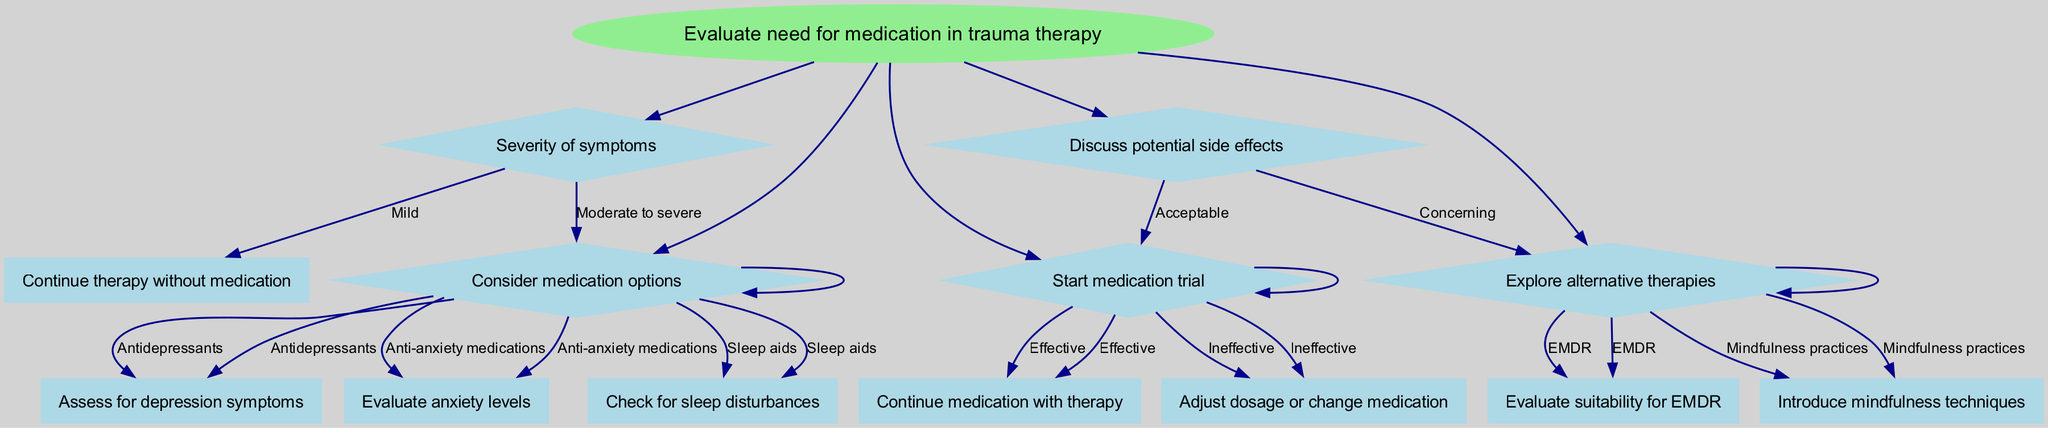What is the root node of the diagram? The root node of the diagram is the main starting point and is labeled as "Evaluate need for medication in trauma therapy."
Answer: Evaluate need for medication in trauma therapy How many main branches are present in the diagram? The diagram has five main branches stemming from the root node, which cover various aspects of evaluating medication needs in trauma therapy.
Answer: Five What are the first options provided under the "Severity of symptoms" node? The "Severity of symptoms" node offers two options: "Mild" and "Moderate to severe."
Answer: Mild, Moderate to severe If the options for medication are selected, what is the next step after "Consider medication options"? After selecting medication options, the next steps involve assessing specific symptoms based on the type of medication considered, such as depression symptoms, anxiety levels, or sleep disturbances.
Answer: Assess for depression symptoms, evaluate anxiety levels, check for sleep disturbances What happens if the side effects of medication are concerning? If side effects are concerning, the next step is to explore alternative therapies, rather than starting the medication trial.
Answer: Explore alternative therapies What follows if the "Start medication trial" is deemed effective? If the medication trial is effective, the next step is to continue the medication in conjunction with therapy.
Answer: Continue medication with therapy How does the diagram treat the "Explore alternative therapies" option if EMDR is chosen? If EMDR is selected under "Explore alternative therapies," the next step is to evaluate the suitability for EMDR as a therapeutic option.
Answer: Evaluate suitability for EMDR What type of shape represents the nodes containing choices in the diagram? The nodes that contain choices are represented in the diagram using a diamond shape, illustrating decision points with various options.
Answer: Diamond What should be evaluated if "Anti-anxiety medications" are selected under "Consider medication options"? If "Anti-anxiety medications" are chosen, the next evaluation focuses on the individual's anxiety levels to determine the appropriateness of the medication.
Answer: Evaluate anxiety levels 